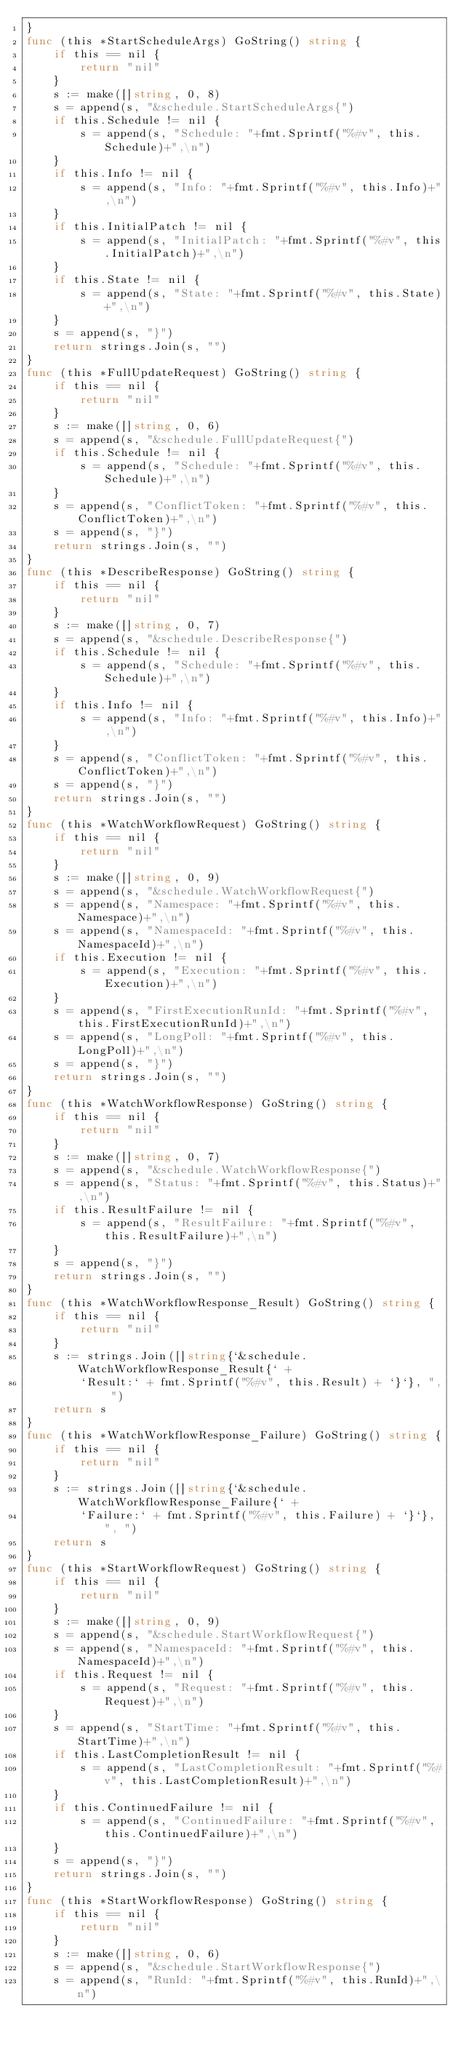<code> <loc_0><loc_0><loc_500><loc_500><_Go_>}
func (this *StartScheduleArgs) GoString() string {
	if this == nil {
		return "nil"
	}
	s := make([]string, 0, 8)
	s = append(s, "&schedule.StartScheduleArgs{")
	if this.Schedule != nil {
		s = append(s, "Schedule: "+fmt.Sprintf("%#v", this.Schedule)+",\n")
	}
	if this.Info != nil {
		s = append(s, "Info: "+fmt.Sprintf("%#v", this.Info)+",\n")
	}
	if this.InitialPatch != nil {
		s = append(s, "InitialPatch: "+fmt.Sprintf("%#v", this.InitialPatch)+",\n")
	}
	if this.State != nil {
		s = append(s, "State: "+fmt.Sprintf("%#v", this.State)+",\n")
	}
	s = append(s, "}")
	return strings.Join(s, "")
}
func (this *FullUpdateRequest) GoString() string {
	if this == nil {
		return "nil"
	}
	s := make([]string, 0, 6)
	s = append(s, "&schedule.FullUpdateRequest{")
	if this.Schedule != nil {
		s = append(s, "Schedule: "+fmt.Sprintf("%#v", this.Schedule)+",\n")
	}
	s = append(s, "ConflictToken: "+fmt.Sprintf("%#v", this.ConflictToken)+",\n")
	s = append(s, "}")
	return strings.Join(s, "")
}
func (this *DescribeResponse) GoString() string {
	if this == nil {
		return "nil"
	}
	s := make([]string, 0, 7)
	s = append(s, "&schedule.DescribeResponse{")
	if this.Schedule != nil {
		s = append(s, "Schedule: "+fmt.Sprintf("%#v", this.Schedule)+",\n")
	}
	if this.Info != nil {
		s = append(s, "Info: "+fmt.Sprintf("%#v", this.Info)+",\n")
	}
	s = append(s, "ConflictToken: "+fmt.Sprintf("%#v", this.ConflictToken)+",\n")
	s = append(s, "}")
	return strings.Join(s, "")
}
func (this *WatchWorkflowRequest) GoString() string {
	if this == nil {
		return "nil"
	}
	s := make([]string, 0, 9)
	s = append(s, "&schedule.WatchWorkflowRequest{")
	s = append(s, "Namespace: "+fmt.Sprintf("%#v", this.Namespace)+",\n")
	s = append(s, "NamespaceId: "+fmt.Sprintf("%#v", this.NamespaceId)+",\n")
	if this.Execution != nil {
		s = append(s, "Execution: "+fmt.Sprintf("%#v", this.Execution)+",\n")
	}
	s = append(s, "FirstExecutionRunId: "+fmt.Sprintf("%#v", this.FirstExecutionRunId)+",\n")
	s = append(s, "LongPoll: "+fmt.Sprintf("%#v", this.LongPoll)+",\n")
	s = append(s, "}")
	return strings.Join(s, "")
}
func (this *WatchWorkflowResponse) GoString() string {
	if this == nil {
		return "nil"
	}
	s := make([]string, 0, 7)
	s = append(s, "&schedule.WatchWorkflowResponse{")
	s = append(s, "Status: "+fmt.Sprintf("%#v", this.Status)+",\n")
	if this.ResultFailure != nil {
		s = append(s, "ResultFailure: "+fmt.Sprintf("%#v", this.ResultFailure)+",\n")
	}
	s = append(s, "}")
	return strings.Join(s, "")
}
func (this *WatchWorkflowResponse_Result) GoString() string {
	if this == nil {
		return "nil"
	}
	s := strings.Join([]string{`&schedule.WatchWorkflowResponse_Result{` +
		`Result:` + fmt.Sprintf("%#v", this.Result) + `}`}, ", ")
	return s
}
func (this *WatchWorkflowResponse_Failure) GoString() string {
	if this == nil {
		return "nil"
	}
	s := strings.Join([]string{`&schedule.WatchWorkflowResponse_Failure{` +
		`Failure:` + fmt.Sprintf("%#v", this.Failure) + `}`}, ", ")
	return s
}
func (this *StartWorkflowRequest) GoString() string {
	if this == nil {
		return "nil"
	}
	s := make([]string, 0, 9)
	s = append(s, "&schedule.StartWorkflowRequest{")
	s = append(s, "NamespaceId: "+fmt.Sprintf("%#v", this.NamespaceId)+",\n")
	if this.Request != nil {
		s = append(s, "Request: "+fmt.Sprintf("%#v", this.Request)+",\n")
	}
	s = append(s, "StartTime: "+fmt.Sprintf("%#v", this.StartTime)+",\n")
	if this.LastCompletionResult != nil {
		s = append(s, "LastCompletionResult: "+fmt.Sprintf("%#v", this.LastCompletionResult)+",\n")
	}
	if this.ContinuedFailure != nil {
		s = append(s, "ContinuedFailure: "+fmt.Sprintf("%#v", this.ContinuedFailure)+",\n")
	}
	s = append(s, "}")
	return strings.Join(s, "")
}
func (this *StartWorkflowResponse) GoString() string {
	if this == nil {
		return "nil"
	}
	s := make([]string, 0, 6)
	s = append(s, "&schedule.StartWorkflowResponse{")
	s = append(s, "RunId: "+fmt.Sprintf("%#v", this.RunId)+",\n")</code> 